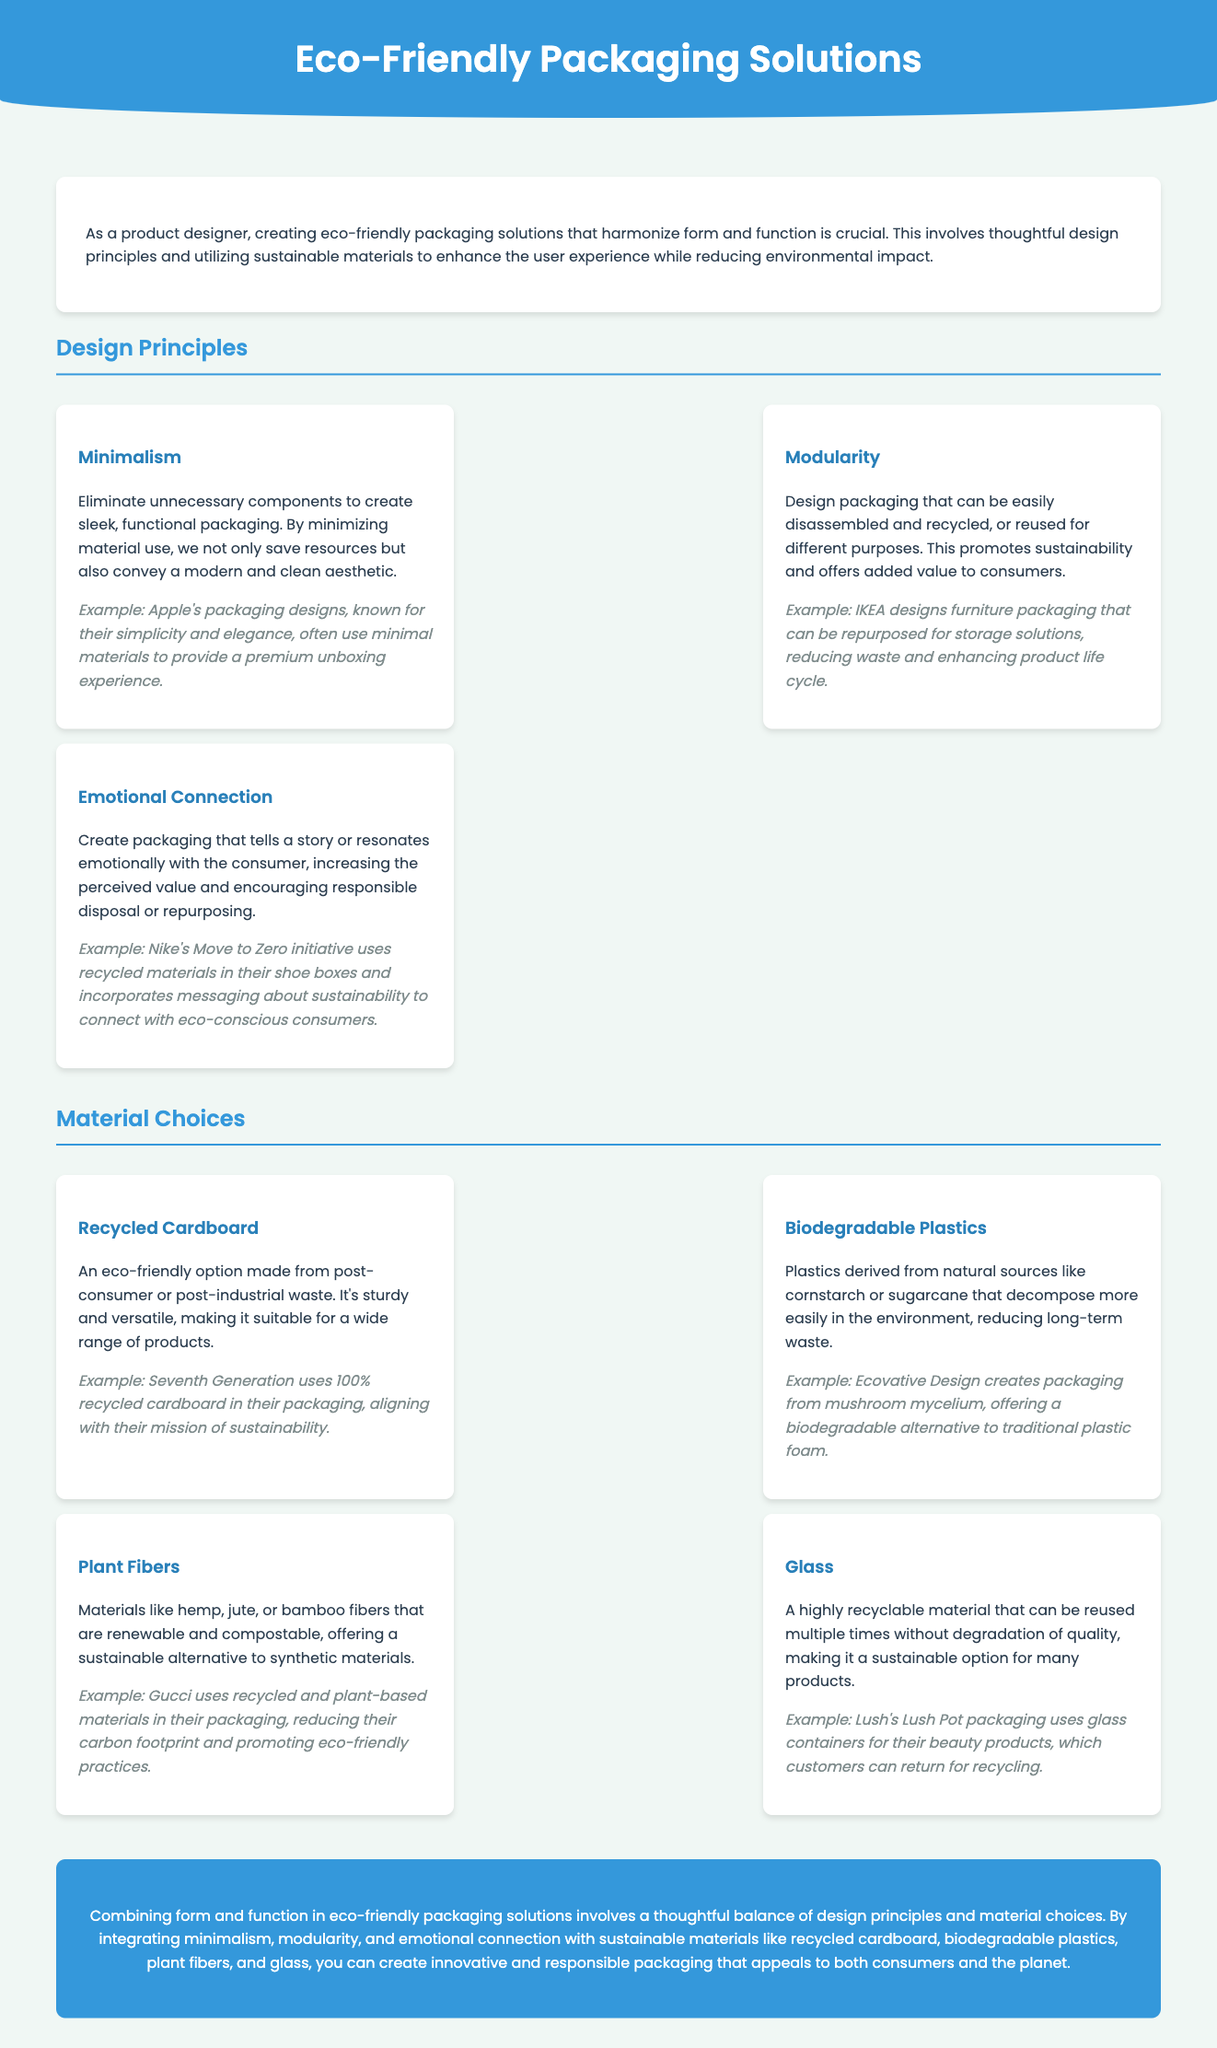What is the main focus of the document? The document focuses on creating eco-friendly packaging solutions that harmonize form and function.
Answer: Eco-friendly packaging solutions What is an example of a minimalism principle? The document provides an example of Apple's packaging designs which use minimal materials.
Answer: Apple's packaging designs What material is made from post-consumer waste? The document states that recycled cardboard is made from post-consumer waste.
Answer: Recycled cardboard Which design principle promotes sustainability through reuse? The document states that modularity promotes sustainability through designing packaging that can be easily reused.
Answer: Modularity What is an example of biodegradable plastics mentioned in the document? The document describes Ecovative Design's packaging made from mushroom mycelium as an example.
Answer: Mushroom mycelium How does emotional connection in packaging enhance consumer experience? The document explains that emotional connection increases perceived value and encourages responsible disposal.
Answer: Increases perceived value What type of fiber is mentioned as renewable and compostable? The document mentions plant fibers like hemp, jute, or bamboo as renewable and compostable.
Answer: Plant fibers What type of packaging does Lush use for their products? The document states that Lush uses glass containers for their beauty products.
Answer: Glass containers What sustainable practice does Gucci apply in their packaging? The document notes that Gucci uses recycled and plant-based materials in their packaging.
Answer: Recycled and plant-based materials 